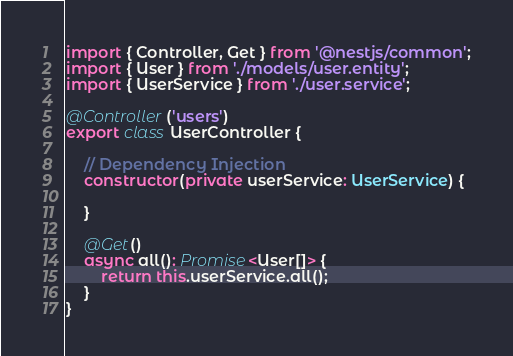<code> <loc_0><loc_0><loc_500><loc_500><_TypeScript_>import { Controller, Get } from '@nestjs/common';
import { User } from './models/user.entity';
import { UserService } from './user.service';

@Controller('users')
export class UserController {

    // Dependency Injection
    constructor(private userService: UserService) {

    }
    
    @Get()
    async all(): Promise<User[]> {
        return this.userService.all();
    }
}
</code> 